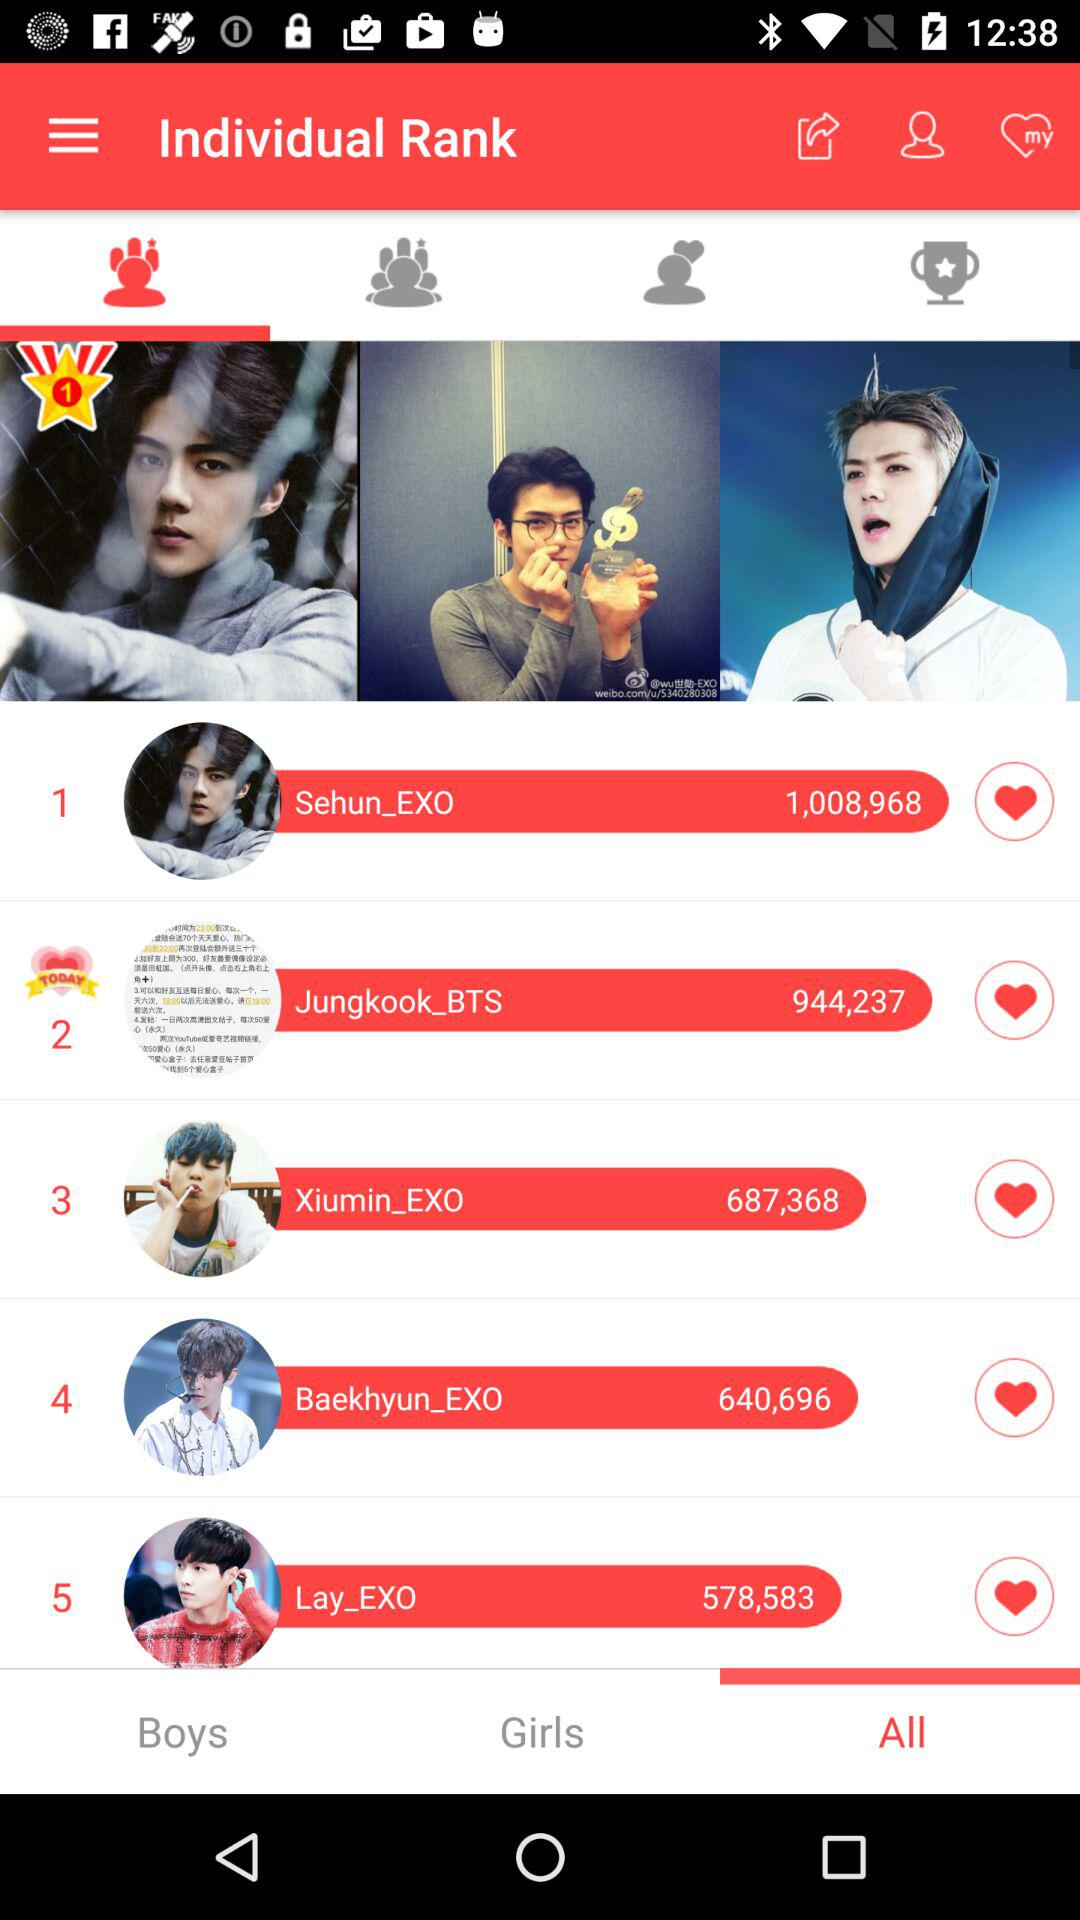What is the rank of "Lay_EXO"? Lay_EXO has rank 5. 